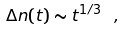<formula> <loc_0><loc_0><loc_500><loc_500>\Delta n ( t ) \sim t ^ { 1 / 3 } \ ,</formula> 